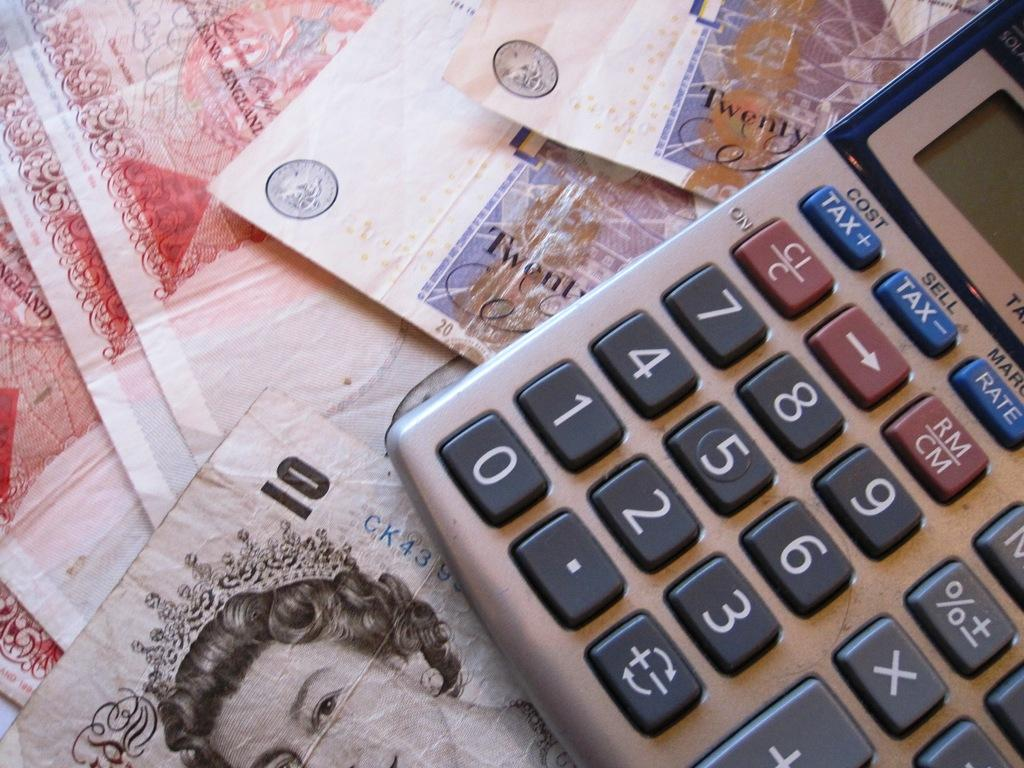<image>
Relay a brief, clear account of the picture shown. Foreign money is on the table next to a calculator that has Tax buttons. 